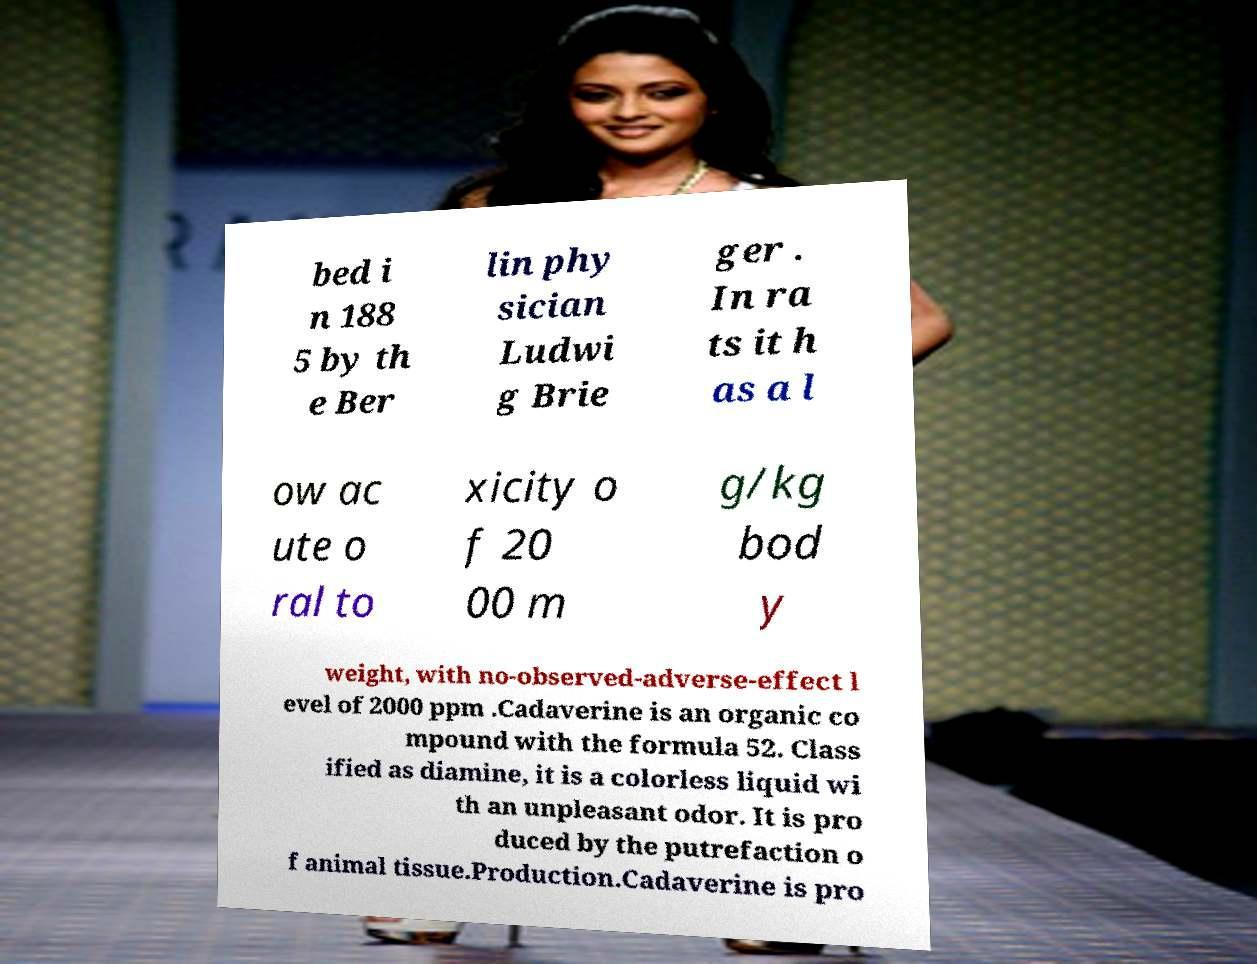Can you read and provide the text displayed in the image?This photo seems to have some interesting text. Can you extract and type it out for me? bed i n 188 5 by th e Ber lin phy sician Ludwi g Brie ger . In ra ts it h as a l ow ac ute o ral to xicity o f 20 00 m g/kg bod y weight, with no-observed-adverse-effect l evel of 2000 ppm .Cadaverine is an organic co mpound with the formula 52. Class ified as diamine, it is a colorless liquid wi th an unpleasant odor. It is pro duced by the putrefaction o f animal tissue.Production.Cadaverine is pro 